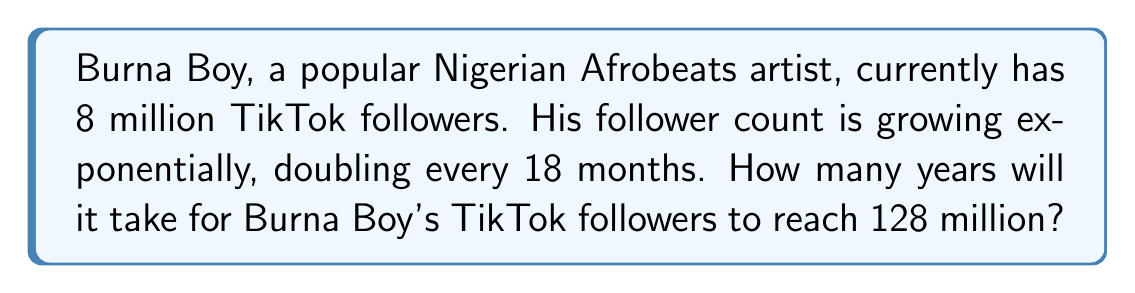What is the answer to this math problem? Let's approach this step-by-step using logarithmic equations:

1) Let $y$ be the number of years and $f(y)$ be the number of followers after $y$ years.

2) We know that the initial number of followers is 8 million and it doubles every 1.5 years.
   So we can write the exponential growth function as:

   $f(y) = 8 \cdot 2^{\frac{y}{1.5}}$

3) We want to find $y$ when $f(y) = 128$ million:

   $128 = 8 \cdot 2^{\frac{y}{1.5}}$

4) Divide both sides by 8:

   $16 = 2^{\frac{y}{1.5}}$

5) Take the logarithm (base 2) of both sides:

   $\log_2(16) = \log_2(2^{\frac{y}{1.5}})$

6) Simplify the left side and use the logarithm property on the right:

   $4 = \frac{y}{1.5}$

7) Multiply both sides by 1.5:

   $6 = y$

Therefore, it will take 6 years for Burna Boy's TikTok followers to reach 128 million.
Answer: 6 years 